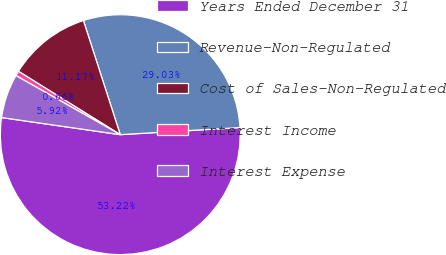Convert chart to OTSL. <chart><loc_0><loc_0><loc_500><loc_500><pie_chart><fcel>Years Ended December 31<fcel>Revenue-Non-Regulated<fcel>Cost of Sales-Non-Regulated<fcel>Interest Income<fcel>Interest Expense<nl><fcel>53.22%<fcel>29.03%<fcel>11.17%<fcel>0.66%<fcel>5.92%<nl></chart> 